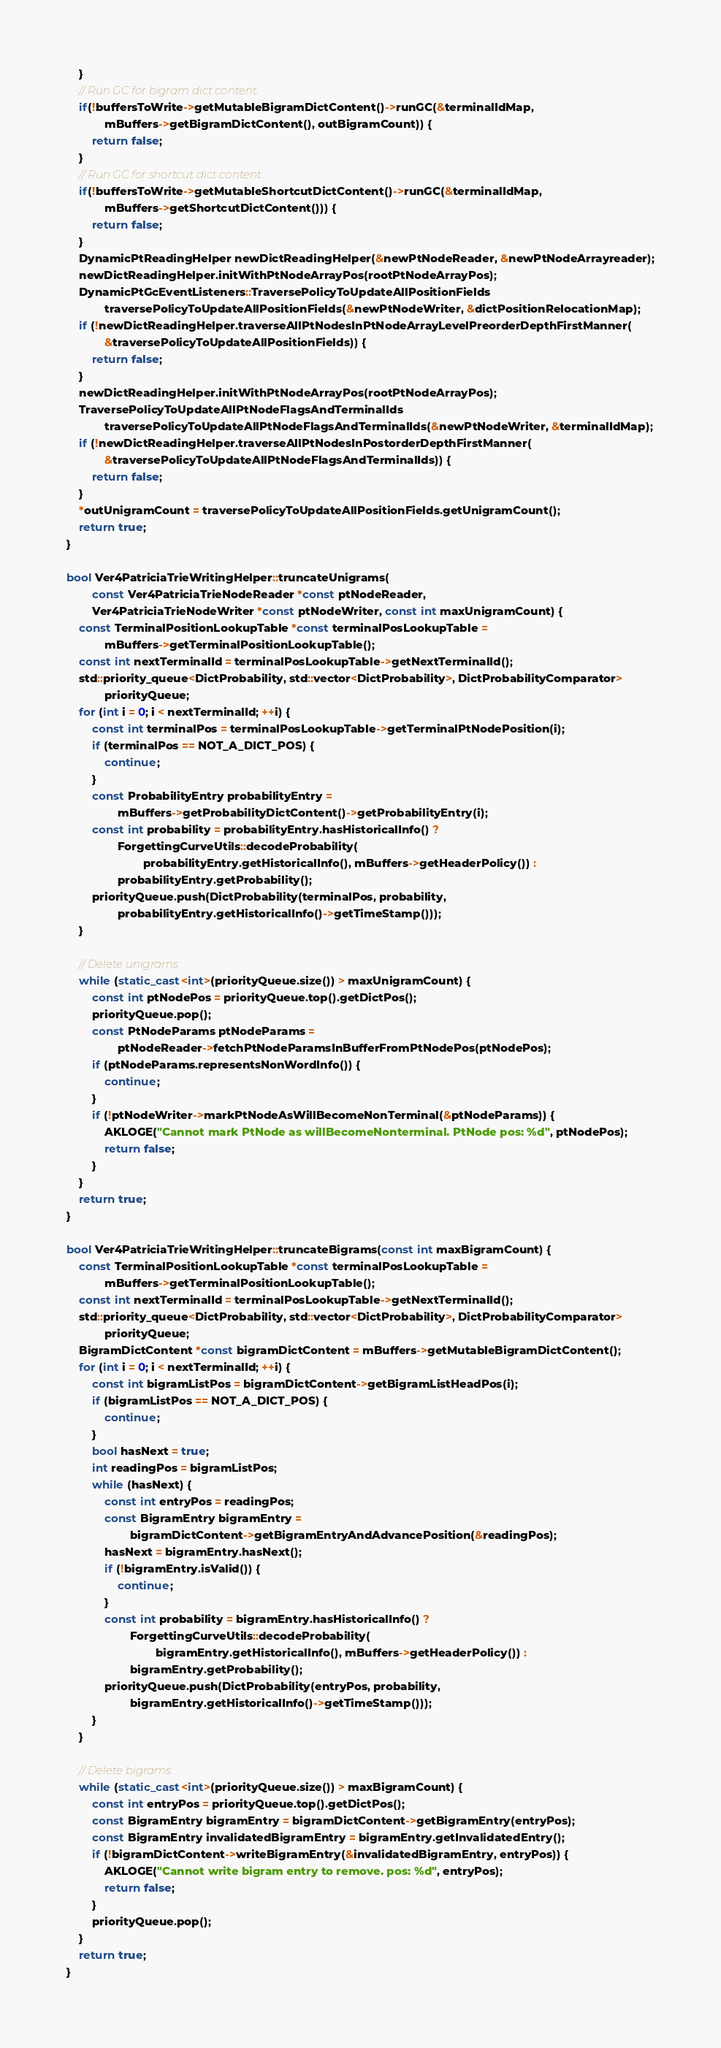Convert code to text. <code><loc_0><loc_0><loc_500><loc_500><_C++_>    }
    // Run GC for bigram dict content.
    if(!buffersToWrite->getMutableBigramDictContent()->runGC(&terminalIdMap,
            mBuffers->getBigramDictContent(), outBigramCount)) {
        return false;
    }
    // Run GC for shortcut dict content.
    if(!buffersToWrite->getMutableShortcutDictContent()->runGC(&terminalIdMap,
            mBuffers->getShortcutDictContent())) {
        return false;
    }
    DynamicPtReadingHelper newDictReadingHelper(&newPtNodeReader, &newPtNodeArrayreader);
    newDictReadingHelper.initWithPtNodeArrayPos(rootPtNodeArrayPos);
    DynamicPtGcEventListeners::TraversePolicyToUpdateAllPositionFields
            traversePolicyToUpdateAllPositionFields(&newPtNodeWriter, &dictPositionRelocationMap);
    if (!newDictReadingHelper.traverseAllPtNodesInPtNodeArrayLevelPreorderDepthFirstManner(
            &traversePolicyToUpdateAllPositionFields)) {
        return false;
    }
    newDictReadingHelper.initWithPtNodeArrayPos(rootPtNodeArrayPos);
    TraversePolicyToUpdateAllPtNodeFlagsAndTerminalIds
            traversePolicyToUpdateAllPtNodeFlagsAndTerminalIds(&newPtNodeWriter, &terminalIdMap);
    if (!newDictReadingHelper.traverseAllPtNodesInPostorderDepthFirstManner(
            &traversePolicyToUpdateAllPtNodeFlagsAndTerminalIds)) {
        return false;
    }
    *outUnigramCount = traversePolicyToUpdateAllPositionFields.getUnigramCount();
    return true;
}

bool Ver4PatriciaTrieWritingHelper::truncateUnigrams(
        const Ver4PatriciaTrieNodeReader *const ptNodeReader,
        Ver4PatriciaTrieNodeWriter *const ptNodeWriter, const int maxUnigramCount) {
    const TerminalPositionLookupTable *const terminalPosLookupTable =
            mBuffers->getTerminalPositionLookupTable();
    const int nextTerminalId = terminalPosLookupTable->getNextTerminalId();
    std::priority_queue<DictProbability, std::vector<DictProbability>, DictProbabilityComparator>
            priorityQueue;
    for (int i = 0; i < nextTerminalId; ++i) {
        const int terminalPos = terminalPosLookupTable->getTerminalPtNodePosition(i);
        if (terminalPos == NOT_A_DICT_POS) {
            continue;
        }
        const ProbabilityEntry probabilityEntry =
                mBuffers->getProbabilityDictContent()->getProbabilityEntry(i);
        const int probability = probabilityEntry.hasHistoricalInfo() ?
                ForgettingCurveUtils::decodeProbability(
                        probabilityEntry.getHistoricalInfo(), mBuffers->getHeaderPolicy()) :
                probabilityEntry.getProbability();
        priorityQueue.push(DictProbability(terminalPos, probability,
                probabilityEntry.getHistoricalInfo()->getTimeStamp()));
    }

    // Delete unigrams.
    while (static_cast<int>(priorityQueue.size()) > maxUnigramCount) {
        const int ptNodePos = priorityQueue.top().getDictPos();
        priorityQueue.pop();
        const PtNodeParams ptNodeParams =
                ptNodeReader->fetchPtNodeParamsInBufferFromPtNodePos(ptNodePos);
        if (ptNodeParams.representsNonWordInfo()) {
            continue;
        }
        if (!ptNodeWriter->markPtNodeAsWillBecomeNonTerminal(&ptNodeParams)) {
            AKLOGE("Cannot mark PtNode as willBecomeNonterminal. PtNode pos: %d", ptNodePos);
            return false;
        }
    }
    return true;
}

bool Ver4PatriciaTrieWritingHelper::truncateBigrams(const int maxBigramCount) {
    const TerminalPositionLookupTable *const terminalPosLookupTable =
            mBuffers->getTerminalPositionLookupTable();
    const int nextTerminalId = terminalPosLookupTable->getNextTerminalId();
    std::priority_queue<DictProbability, std::vector<DictProbability>, DictProbabilityComparator>
            priorityQueue;
    BigramDictContent *const bigramDictContent = mBuffers->getMutableBigramDictContent();
    for (int i = 0; i < nextTerminalId; ++i) {
        const int bigramListPos = bigramDictContent->getBigramListHeadPos(i);
        if (bigramListPos == NOT_A_DICT_POS) {
            continue;
        }
        bool hasNext = true;
        int readingPos = bigramListPos;
        while (hasNext) {
            const int entryPos = readingPos;
            const BigramEntry bigramEntry =
                    bigramDictContent->getBigramEntryAndAdvancePosition(&readingPos);
            hasNext = bigramEntry.hasNext();
            if (!bigramEntry.isValid()) {
                continue;
            }
            const int probability = bigramEntry.hasHistoricalInfo() ?
                    ForgettingCurveUtils::decodeProbability(
                            bigramEntry.getHistoricalInfo(), mBuffers->getHeaderPolicy()) :
                    bigramEntry.getProbability();
            priorityQueue.push(DictProbability(entryPos, probability,
                    bigramEntry.getHistoricalInfo()->getTimeStamp()));
        }
    }

    // Delete bigrams.
    while (static_cast<int>(priorityQueue.size()) > maxBigramCount) {
        const int entryPos = priorityQueue.top().getDictPos();
        const BigramEntry bigramEntry = bigramDictContent->getBigramEntry(entryPos);
        const BigramEntry invalidatedBigramEntry = bigramEntry.getInvalidatedEntry();
        if (!bigramDictContent->writeBigramEntry(&invalidatedBigramEntry, entryPos)) {
            AKLOGE("Cannot write bigram entry to remove. pos: %d", entryPos);
            return false;
        }
        priorityQueue.pop();
    }
    return true;
}
</code> 